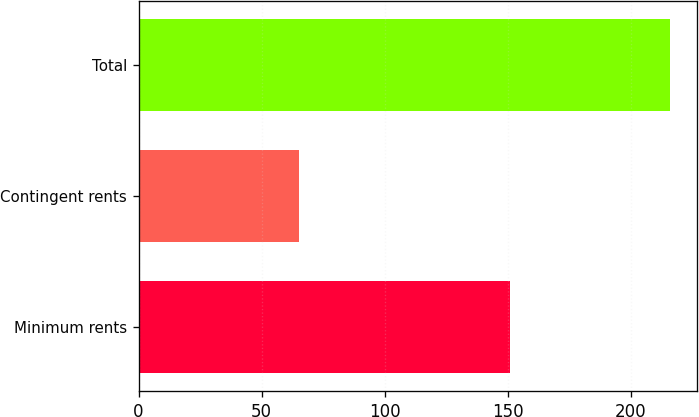Convert chart to OTSL. <chart><loc_0><loc_0><loc_500><loc_500><bar_chart><fcel>Minimum rents<fcel>Contingent rents<fcel>Total<nl><fcel>151<fcel>65<fcel>216<nl></chart> 